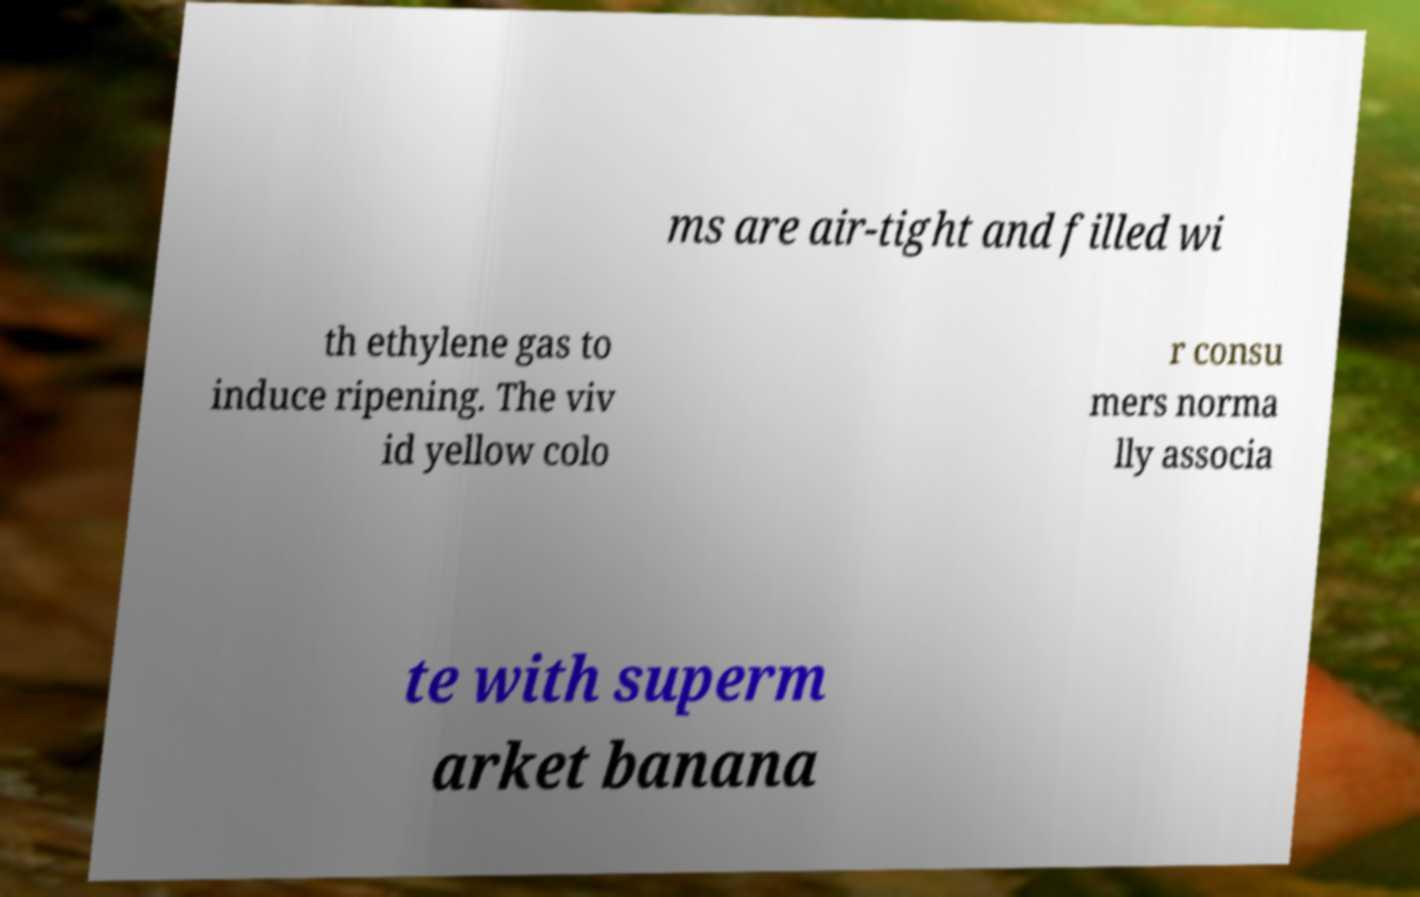I need the written content from this picture converted into text. Can you do that? ms are air-tight and filled wi th ethylene gas to induce ripening. The viv id yellow colo r consu mers norma lly associa te with superm arket banana 